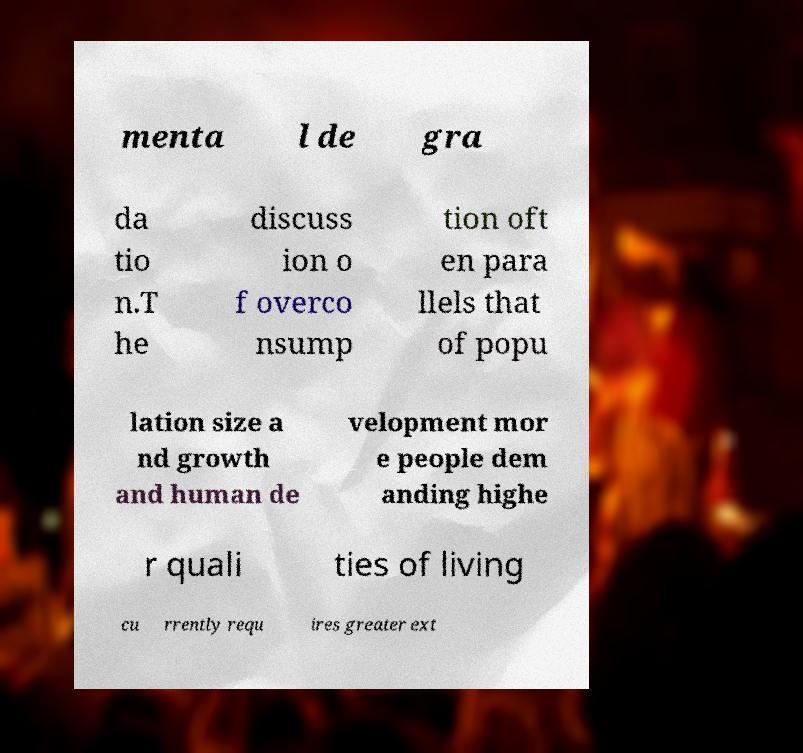Can you accurately transcribe the text from the provided image for me? menta l de gra da tio n.T he discuss ion o f overco nsump tion oft en para llels that of popu lation size a nd growth and human de velopment mor e people dem anding highe r quali ties of living cu rrently requ ires greater ext 